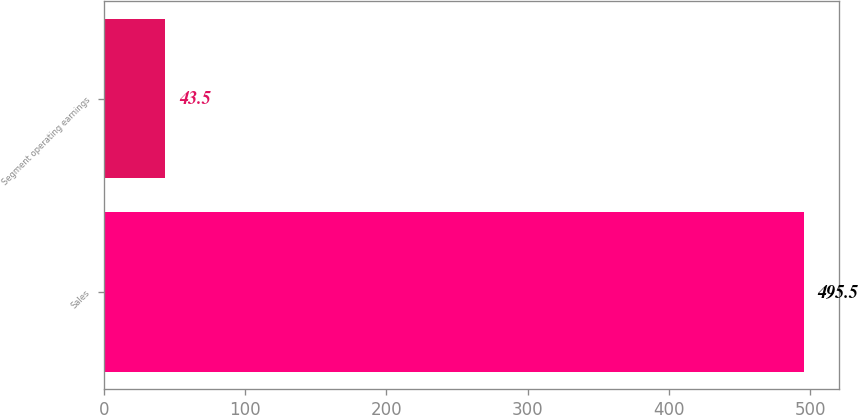Convert chart. <chart><loc_0><loc_0><loc_500><loc_500><bar_chart><fcel>Sales<fcel>Segment operating earnings<nl><fcel>495.5<fcel>43.5<nl></chart> 